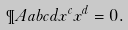Convert formula to latex. <formula><loc_0><loc_0><loc_500><loc_500>\P A { a b } { c d } x ^ { c } x ^ { d } = 0 .</formula> 